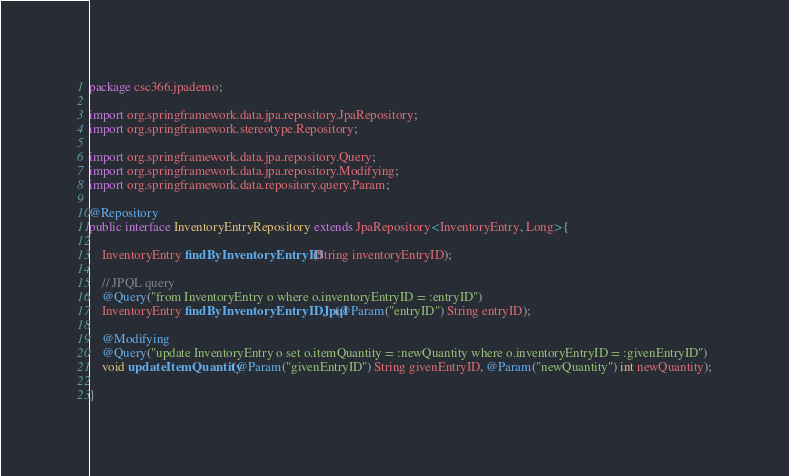Convert code to text. <code><loc_0><loc_0><loc_500><loc_500><_Java_>package csc366.jpademo;

import org.springframework.data.jpa.repository.JpaRepository;
import org.springframework.stereotype.Repository;

import org.springframework.data.jpa.repository.Query;
import org.springframework.data.jpa.repository.Modifying;
import org.springframework.data.repository.query.Param;

@Repository
public interface InventoryEntryRepository extends JpaRepository<InventoryEntry, Long>{

    InventoryEntry findByInventoryEntryID(String inventoryEntryID);

    // JPQL query
    @Query("from InventoryEntry o where o.inventoryEntryID = :entryID")
    InventoryEntry findByInventoryEntryIDJpql(@Param("entryID") String entryID);

    @Modifying
    @Query("update InventoryEntry o set o.itemQuantity = :newQuantity where o.inventoryEntryID = :givenEntryID")
    void updateItemQuantity(@Param("givenEntryID") String givenEntryID, @Param("newQuantity") int newQuantity);

}
</code> 